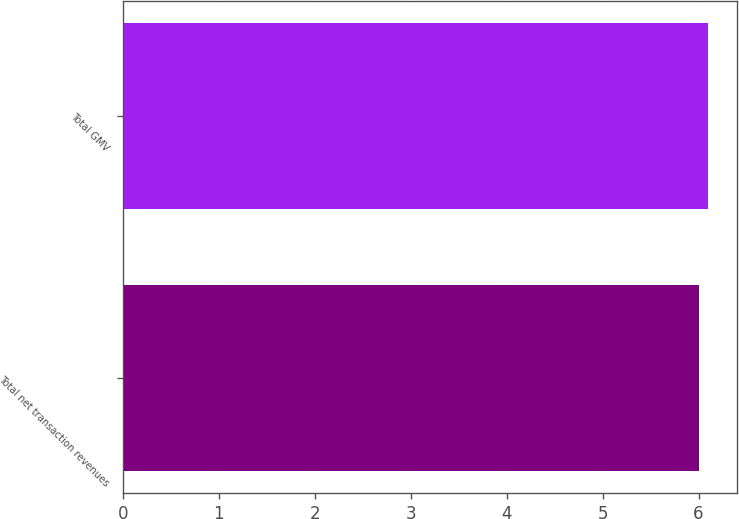Convert chart to OTSL. <chart><loc_0><loc_0><loc_500><loc_500><bar_chart><fcel>Total net transaction revenues<fcel>Total GMV<nl><fcel>6<fcel>6.1<nl></chart> 